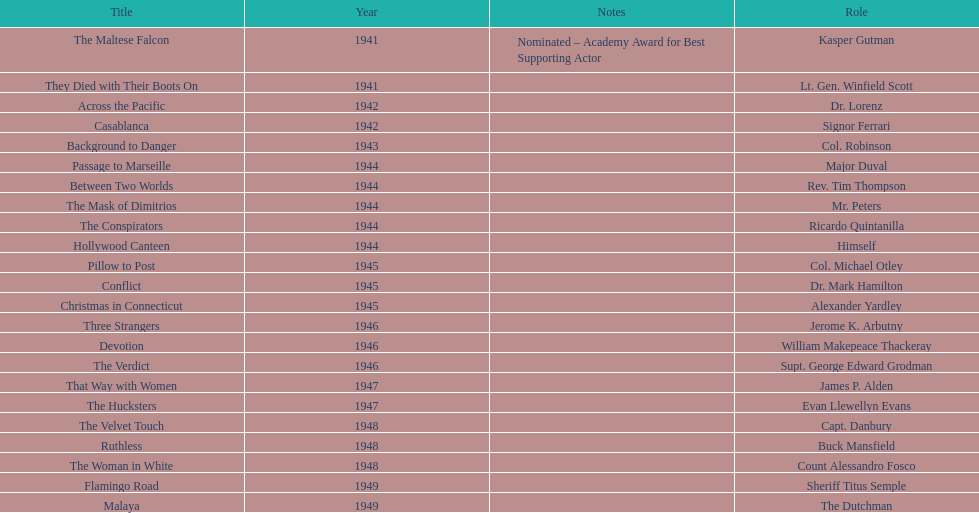What movies did greenstreet act for in 1946? Three Strangers, Devotion, The Verdict. 